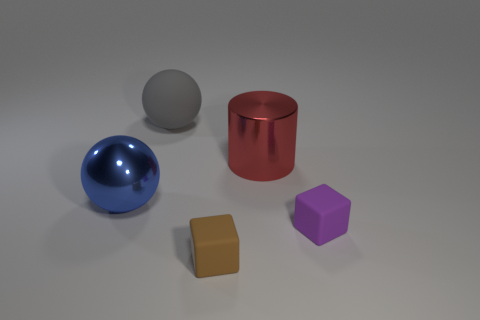What number of other matte things are the same shape as the gray rubber object?
Make the answer very short. 0. Are there fewer large blue spheres that are behind the big gray rubber ball than small purple things on the right side of the metal ball?
Your answer should be very brief. Yes. There is a large metal thing that is behind the large blue object; what number of big red cylinders are in front of it?
Your answer should be compact. 0. Are any small green cubes visible?
Your answer should be very brief. No. Is there a large green object that has the same material as the purple cube?
Offer a terse response. No. Is the number of red objects that are in front of the big gray rubber sphere greater than the number of brown matte cubes that are in front of the tiny brown thing?
Provide a short and direct response. Yes. Is the size of the gray matte sphere the same as the red cylinder?
Provide a short and direct response. Yes. The ball that is to the right of the ball that is to the left of the gray matte ball is what color?
Ensure brevity in your answer.  Gray. The big cylinder has what color?
Your answer should be compact. Red. What number of objects are big gray rubber spheres that are behind the large blue metallic thing or large yellow spheres?
Ensure brevity in your answer.  1. 